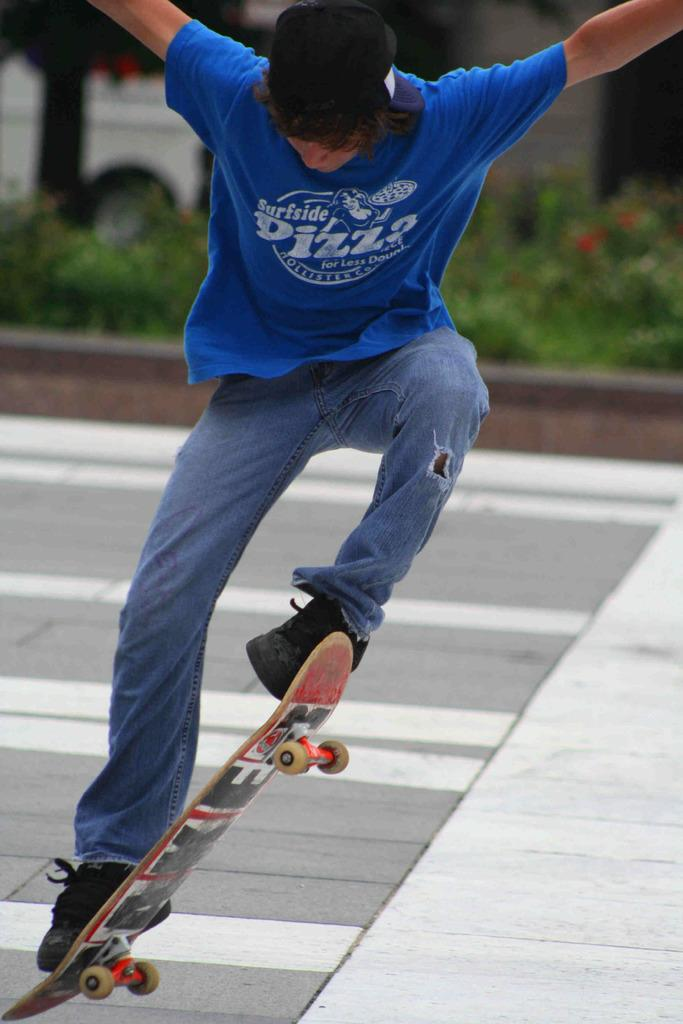What is the main subject of the image? There is a man in the image. What is the man doing in the image? The man is skating on a skateboard. What can be seen in the background of the image? There are plants and a tree visible in the background of the image. Where is the nest located in the image? There is no nest present in the image. Can you describe the grandmother's attire in the image? There is no grandmother present in the image. 